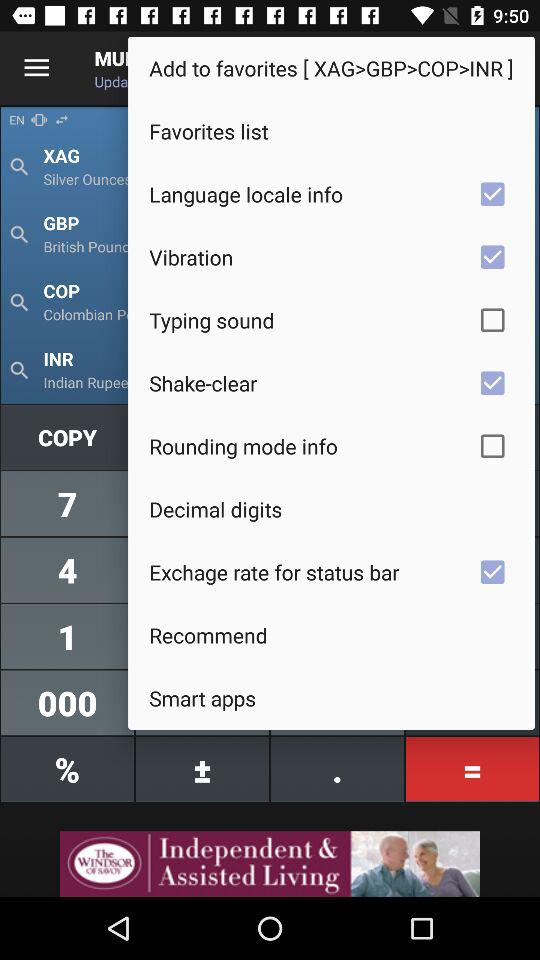What is the status of "Rounding mode info"? The status is "off". 